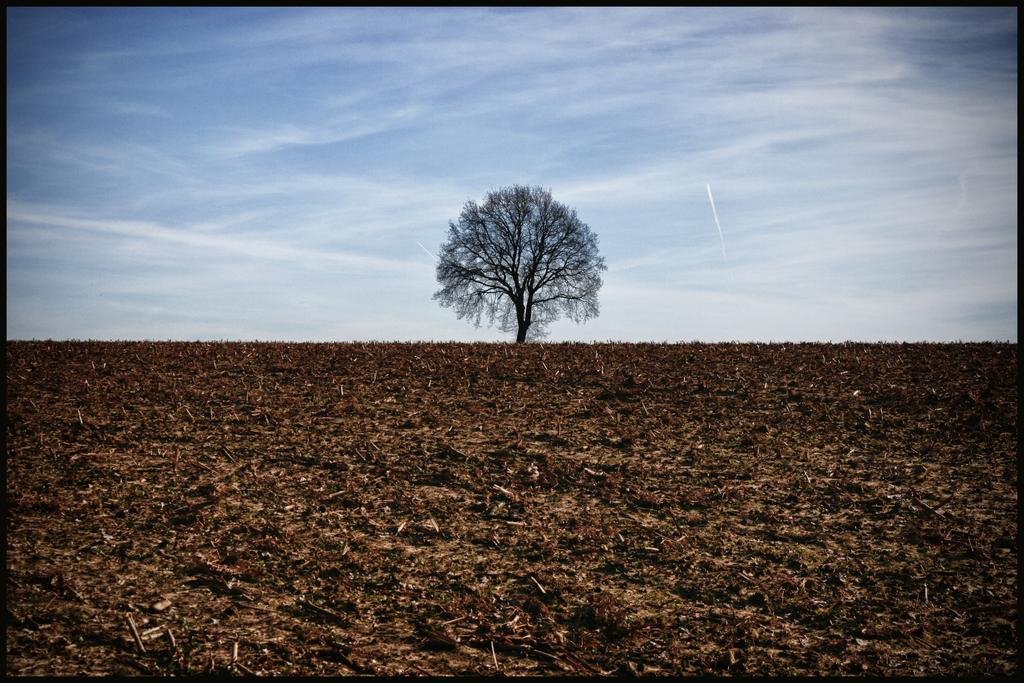What type of natural material can be seen in the image? There are dry leaves in the image. What is located in the background of the image? There is a tree in the background of the image. How would you describe the sky in the image? The sky is cloudy in the image. How many books are stacked on the dirt in the image? There are no books or dirt present in the image; it only features dry leaves and a tree in the background with a cloudy sky. 